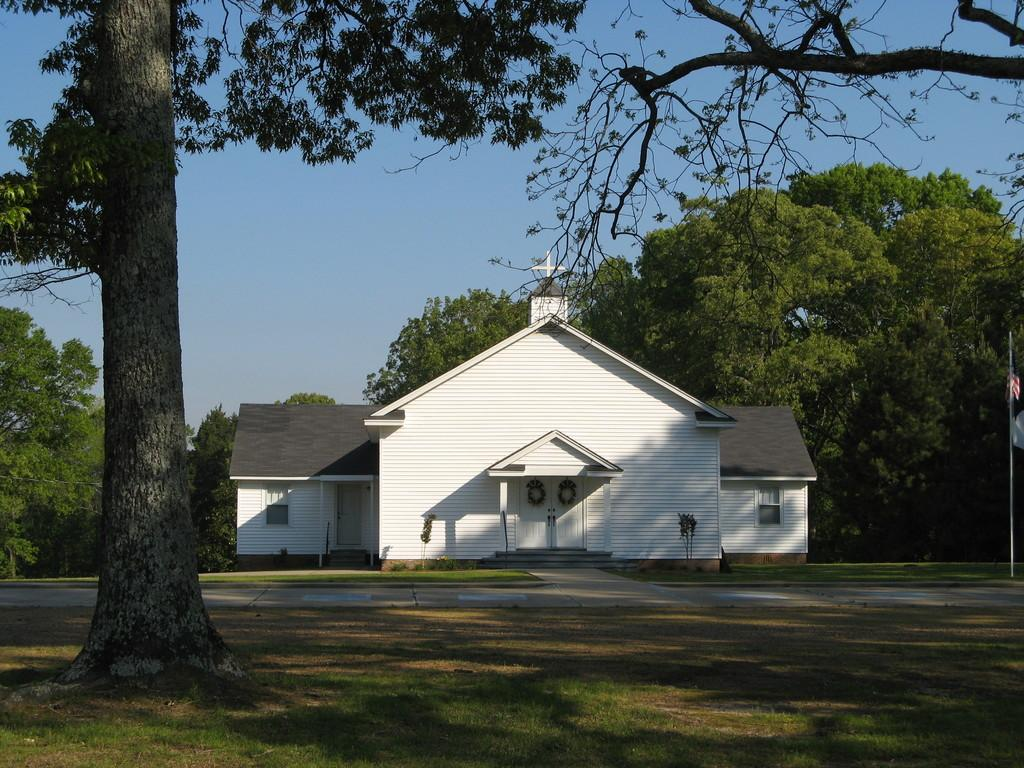What is located on the left side of the image? There is a tree on the left side of the image. What type of terrain surrounds the tree? The tree is on a grass field. What can be seen in the background of the image? There is a home in the background of the image. What is present behind the home? Trees are present behind the home. What is visible above the home and trees? The sky is visible above the home and trees. Can you see any waves in the image? There are no waves present in the image; it features a tree, grass field, home, trees, and sky. What type of quill is used to write on the tree trunk in the image? There is no quill or writing on the tree trunk in the image. 